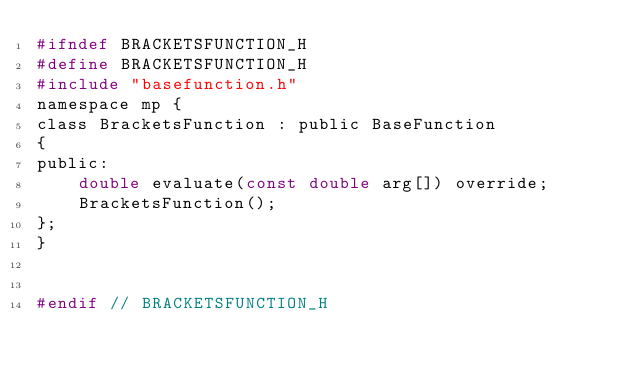<code> <loc_0><loc_0><loc_500><loc_500><_C_>#ifndef BRACKETSFUNCTION_H
#define BRACKETSFUNCTION_H
#include "basefunction.h"
namespace mp {
class BracketsFunction : public BaseFunction
{
public:
    double evaluate(const double arg[]) override;
    BracketsFunction();
};
}


#endif // BRACKETSFUNCTION_H
</code> 